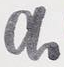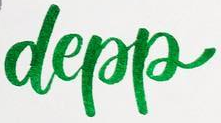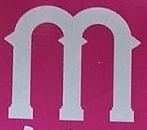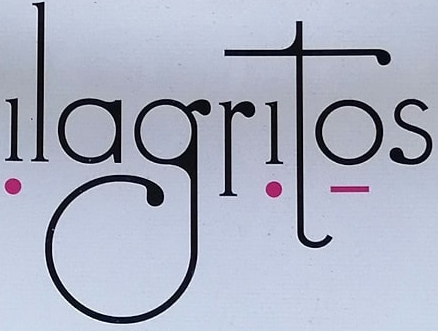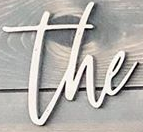What words are shown in these images in order, separated by a semicolon? a; depp; m; ǃlagrǃtọs; the 